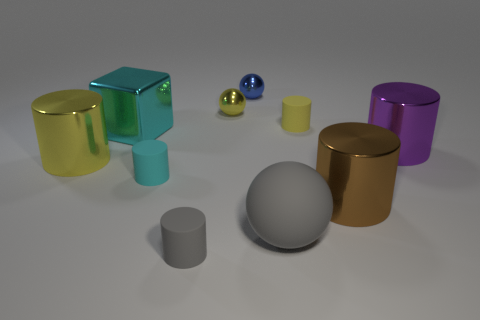Subtract 1 cylinders. How many cylinders are left? 5 Subtract all gray cylinders. How many cylinders are left? 5 Subtract all tiny gray cylinders. How many cylinders are left? 5 Subtract all red cylinders. Subtract all brown blocks. How many cylinders are left? 6 Subtract all balls. How many objects are left? 7 Add 8 purple cylinders. How many purple cylinders exist? 9 Subtract 1 brown cylinders. How many objects are left? 9 Subtract all big cylinders. Subtract all big metallic blocks. How many objects are left? 6 Add 3 purple cylinders. How many purple cylinders are left? 4 